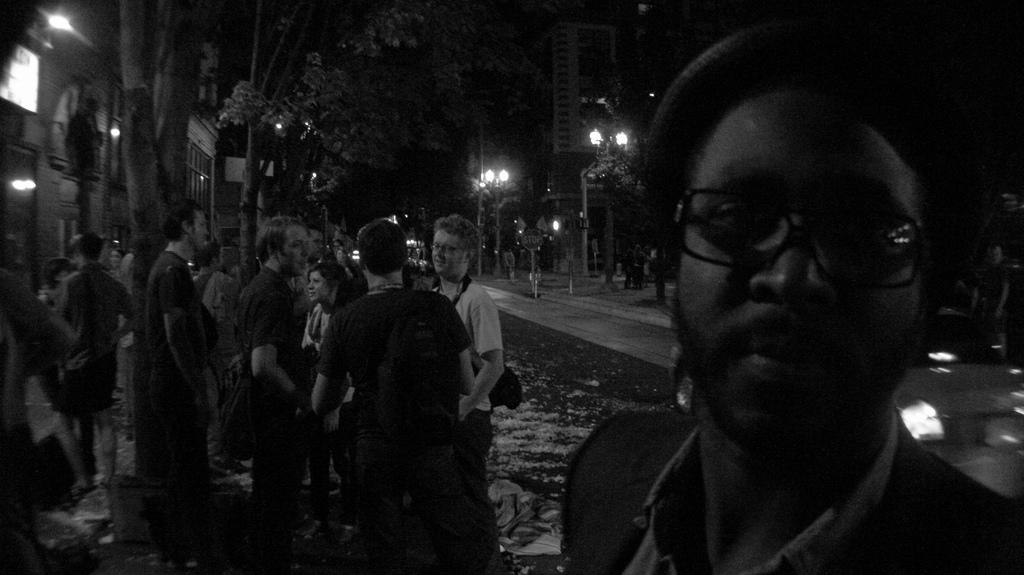How many people can be seen in the image? There are people in the image, but the exact number is not specified. What type of vehicle is on the road in the image? The fact does not specify the type of vehicle, only that there is a vehicle on the road. What structures are visible in the image? There are buildings in the image. What is the purpose of the board in the image? The purpose of the board is not specified in the facts. What are the poles used for in the image? The purpose of the poles is not specified in the facts. What type of lights are present in the image? The fact does not specify the type of lights, only that there are lights in the image. What type of vegetation is visible in the image? There are trees in the image. What is the color of the background in the image? The background of the image is dark. What type of linen is being used to cover the science experiment in the image? There is no mention of linen or a science experiment in the image. How does the vehicle move in the image? The fact does not specify the movement of the vehicle, only that there is a vehicle on the road. 